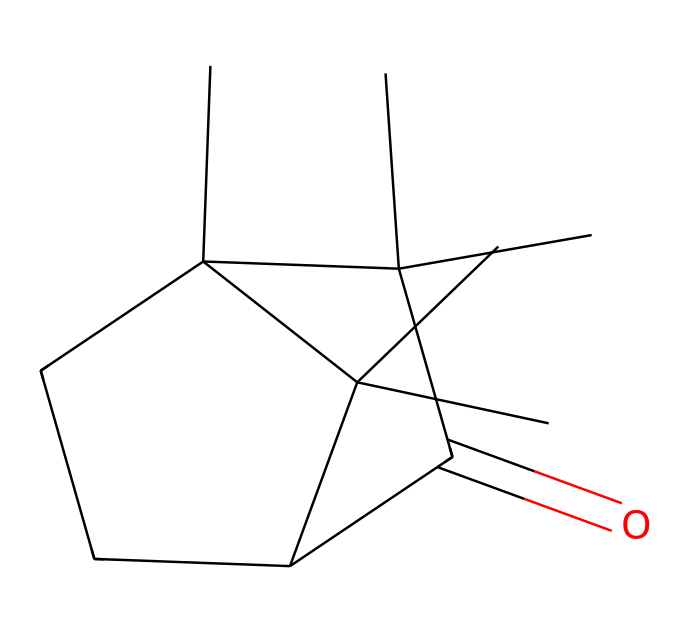How many carbon atoms are in camphor? The provided SMILES representation indicates that the structure contains a total of 15 carbon atoms (C). This is counted directly from the structure depicted in the SMILES.
Answer: 15 What functional group is present in camphor? The presence of the carbonyl group (C=O) within the SMILES indicates that camphor is a ketone. The location of the carbonyl bond confirms that it is indeed a ketone.
Answer: ketone How many chiral centers are present in camphor? By analyzing the structure, we can identify two carbon atoms that are bonded to four different substituents, indicating the presence of two chiral centers in the molecule.
Answer: 2 What is the degree of saturation of camphor? The formula for degree of saturation (also known as the hydrogen deficiency index) is determined by the number of rings and double bonds in the structure. In camphor, there are multiple rings and a carbonyl group contributing to the overall saturation. Upon assessment, the degree of saturation is found to be 4.
Answer: 4 What type of ketone is camphor? Camphor is classified as a bicyclic ketone due to its fused ring structure shown in the SMILES notation, indicating its complexity and specific cyclic arrangement.
Answer: bicyclic 